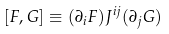Convert formula to latex. <formula><loc_0><loc_0><loc_500><loc_500>[ F , G ] \equiv ( \partial _ { i } F ) J ^ { i j } ( \partial _ { j } G )</formula> 